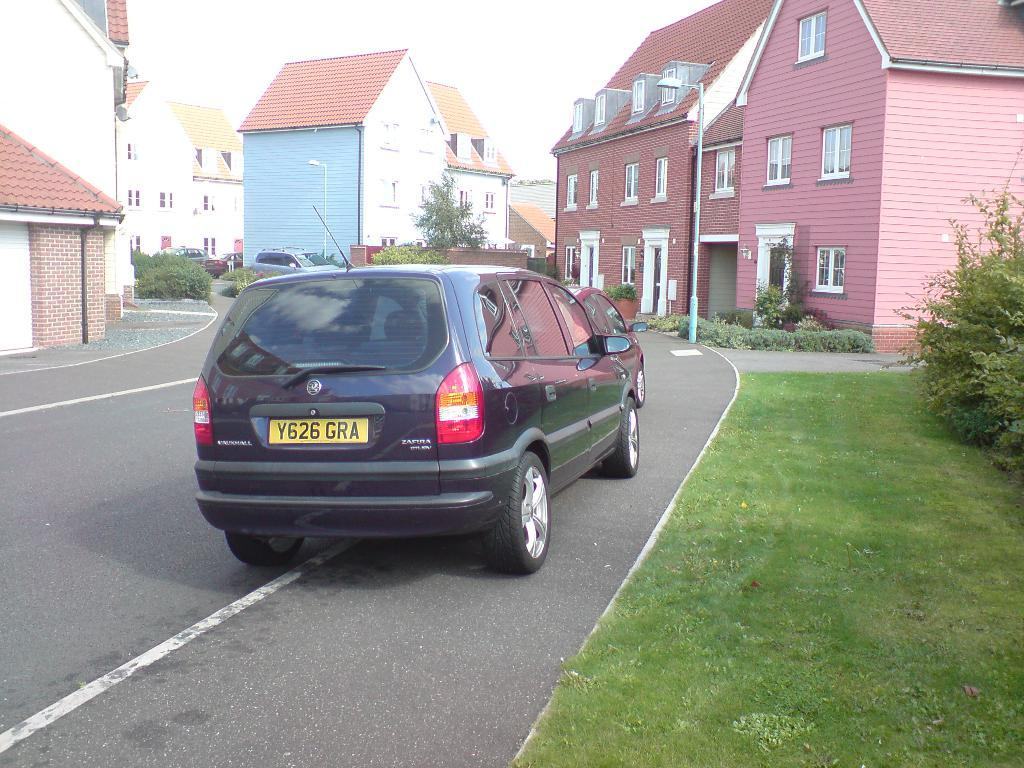<image>
Provide a brief description of the given image. A blue vehicle that says Zafura is parked on the side of a road with pink houses. 